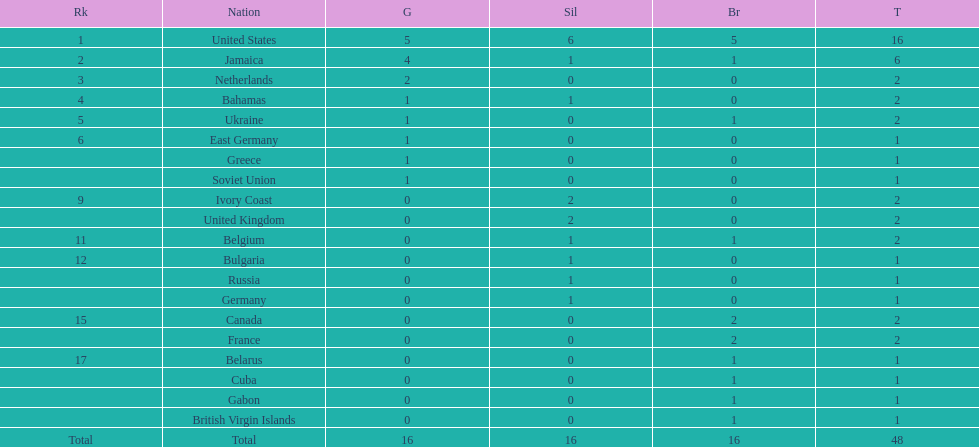How many nations won at least two gold medals? 3. 